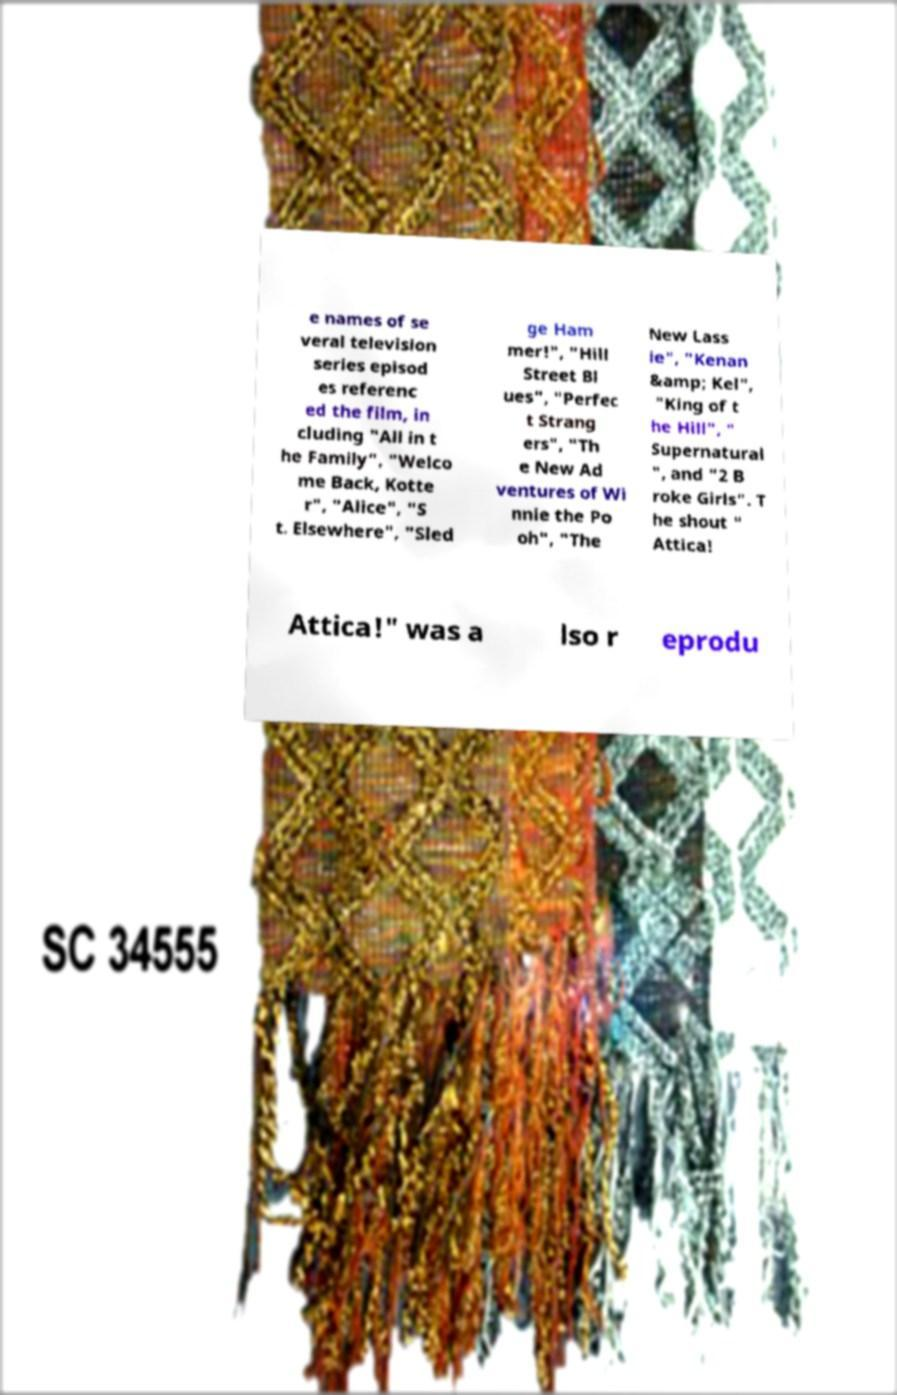Please identify and transcribe the text found in this image. e names of se veral television series episod es referenc ed the film, in cluding "All in t he Family", "Welco me Back, Kotte r", "Alice", "S t. Elsewhere", "Sled ge Ham mer!", "Hill Street Bl ues", "Perfec t Strang ers", "Th e New Ad ventures of Wi nnie the Po oh", "The New Lass ie", "Kenan &amp; Kel", "King of t he Hill", " Supernatural ", and "2 B roke Girls". T he shout " Attica! Attica!" was a lso r eprodu 